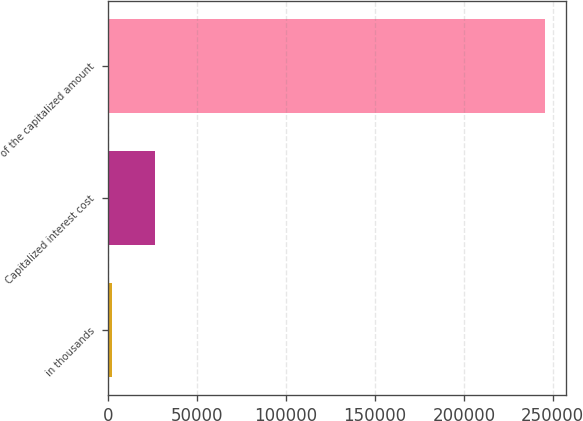Convert chart to OTSL. <chart><loc_0><loc_0><loc_500><loc_500><bar_chart><fcel>in thousands<fcel>Capitalized interest cost<fcel>of the capitalized amount<nl><fcel>2014<fcel>26358.5<fcel>245459<nl></chart> 